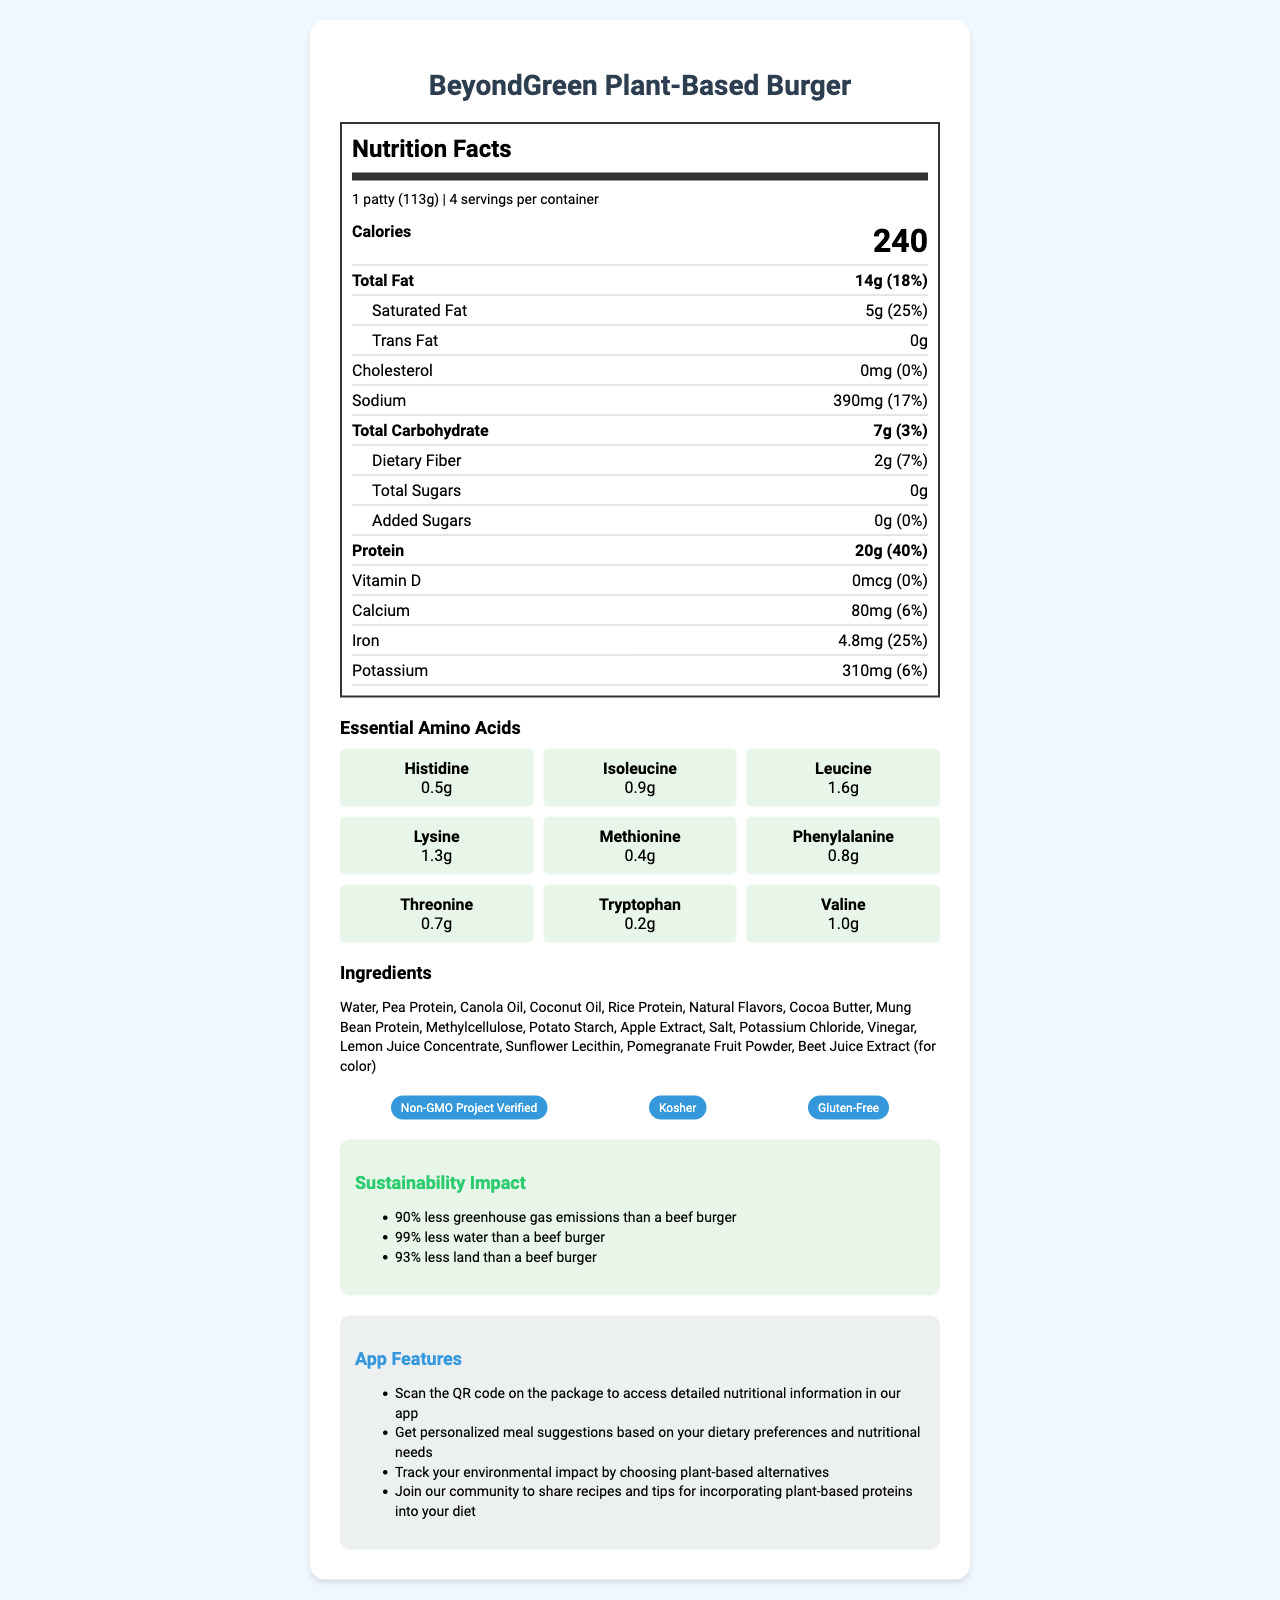What is the serving size of the BeyondGreen Plant-Based Burger? The serving size is stated at the top of the nutrition label section.
Answer: 1 patty (113g) How many servings are in a container of BeyondGreen Plant-Based Burger? The servings per container are mentioned right next to the serving size.
Answer: 4 How many calories are in one serving of the BeyondGreen Plant-Based Burger? The calorie count for one serving is prominently displayed under the serving info.
Answer: 240 What is the amount of total fat in one serving, and its percent daily value? The total fat amount and its daily value percent are listed together in the nutrition facts.
Answer: 14g, 18% What is the protein content for one serving of BeyondGreen Plant-Based Burger? The amount of protein per serving is provided in the bold section of the nutrition label.
Answer: 20g What is the percent daily value for added sugars? The percent daily value for added sugars is indicated as 0% on the label.
Answer: 0% Which of the following certifications does the BeyondGreen Plant-Based Burger have? A. USDA Organic B. Non-GMO Project Verified C. Fair Trade Certified D. Certified Humane The certifications listed are Non-GMO Project Verified, Kosher, and Gluten-Free.
Answer: B Which essential amino acid is present in the highest amount? A. Histidine B. Isoleucine C. Leucine D. Valine Leucine is listed with an amount of 1.6g, which is the highest among the essential amino acids.
Answer: C Is the product gluten-free? The product's certifications include a Gluten-Free certification.
Answer: Yes Summarize the nutritional profile and key features of the BeyondGreen Plant-Based Burger. The document highlights the nutritional content, certifications, sustainable impact, and app features associated with the BeyondGreen Plant-Based Burger.
Answer: The BeyondGreen Plant-Based Burger provides 240 calories per serving, with a focus on high protein content (20g) and essential amino acids. It has minimal sugars and no cholesterol. Key certifications include Non-GMO Project Verified, Kosher, and Gluten-Free. Sustainability features highlight a significant reduction in greenhouse gas emissions, water, and land usage compared to traditional beef burgers. Additional app features include detailed nutritional info, personalized meal suggestions, and community engagement. What is the range of amounts for essential amino acids in this product? The essential amino acids section lists the specific amounts ranging from 0.2g to 1.6g.
Answer: Between 0.2g (Tryptophan) and 1.6g (Leucine) How much sodium does one serving contain? The amount of sodium per serving is specified in the nutrition facts section.
Answer: 390mg What is the primary source of protein in the BeyondGreen Plant-Based Burger? The ingredients list shows Pea Protein as the second item, indicating it as a primary source of protein.
Answer: Pea Protein Can you determine the price of the BeyondGreen Plant-Based Burger from this document? The document provides nutritional, certification, and feature details but does not mention the price.
Answer: Not enough information Describe one sustainable benefit of choosing this plant-based burger over a beef burger. One of the sustainability benefits listed is that the product results in 90% less greenhouse gas emissions than a beef burger.
Answer: 90% less greenhouse gas emissions 